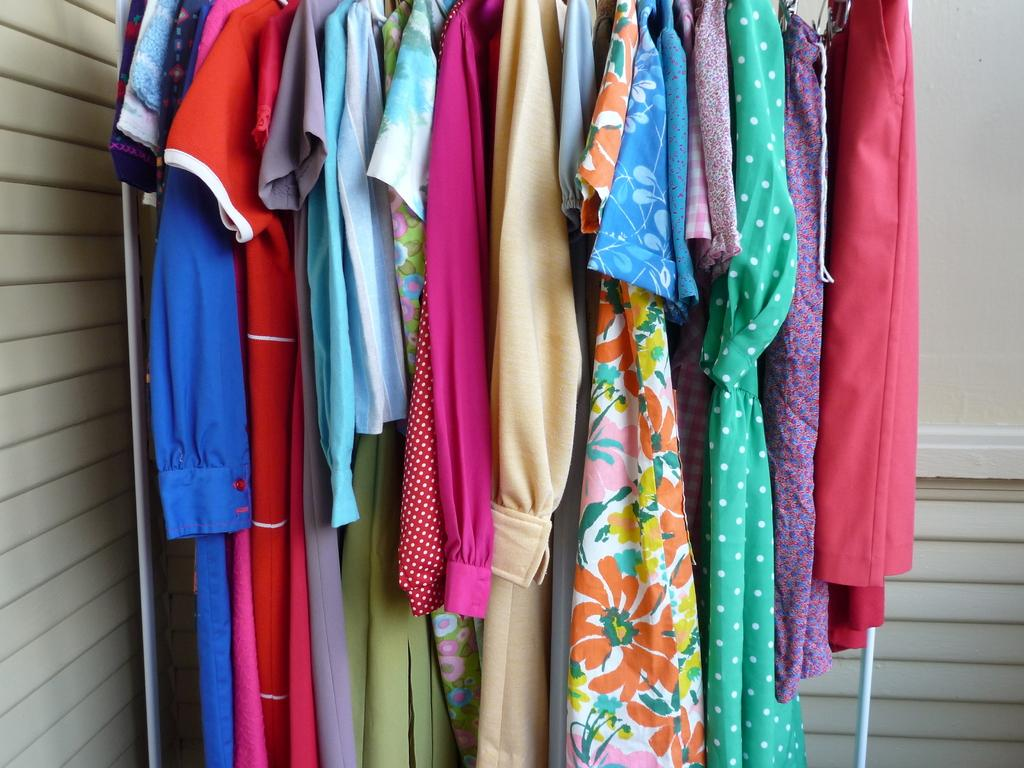Where was the image taken? The image was taken indoors. What can be seen in the background of the image? There is a wall in the background of the image. What is the main subject of the image? The main subject of the image is clothes on a hanger. Can you see any fish swimming in the image? No, there are no fish present in the image. How does the person touch the clothes on the hanger in the image? The image does not show a person touching the clothes on the hanger, so it cannot be determined from the image. 